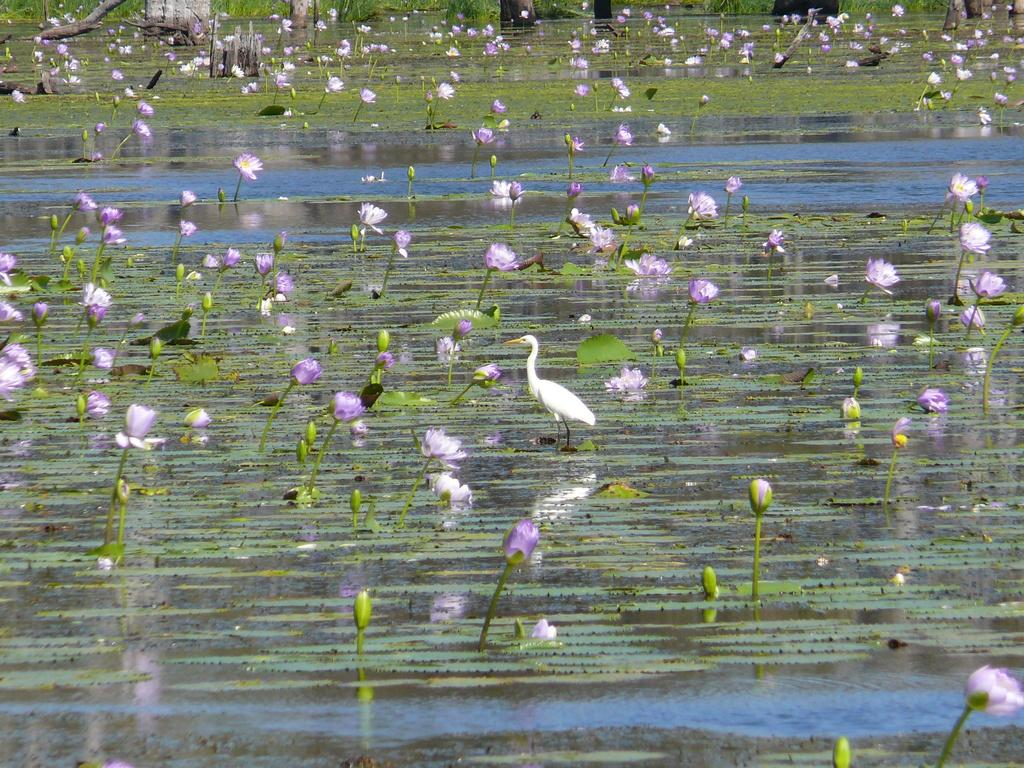What type of flowers are in the water in the image? There are lotus flowers in the water. What else can be seen floating on the water? There is algae floating on the water. What animal is present in the water in the image? There is a crane bird in the water. Where is the crane bird located in the image? The crane bird is in the middle of the picture. What type of dust can be seen on the rail in the image? There is no rail or dust present in the image; it features lotus flowers, algae, and a crane bird in the water. 